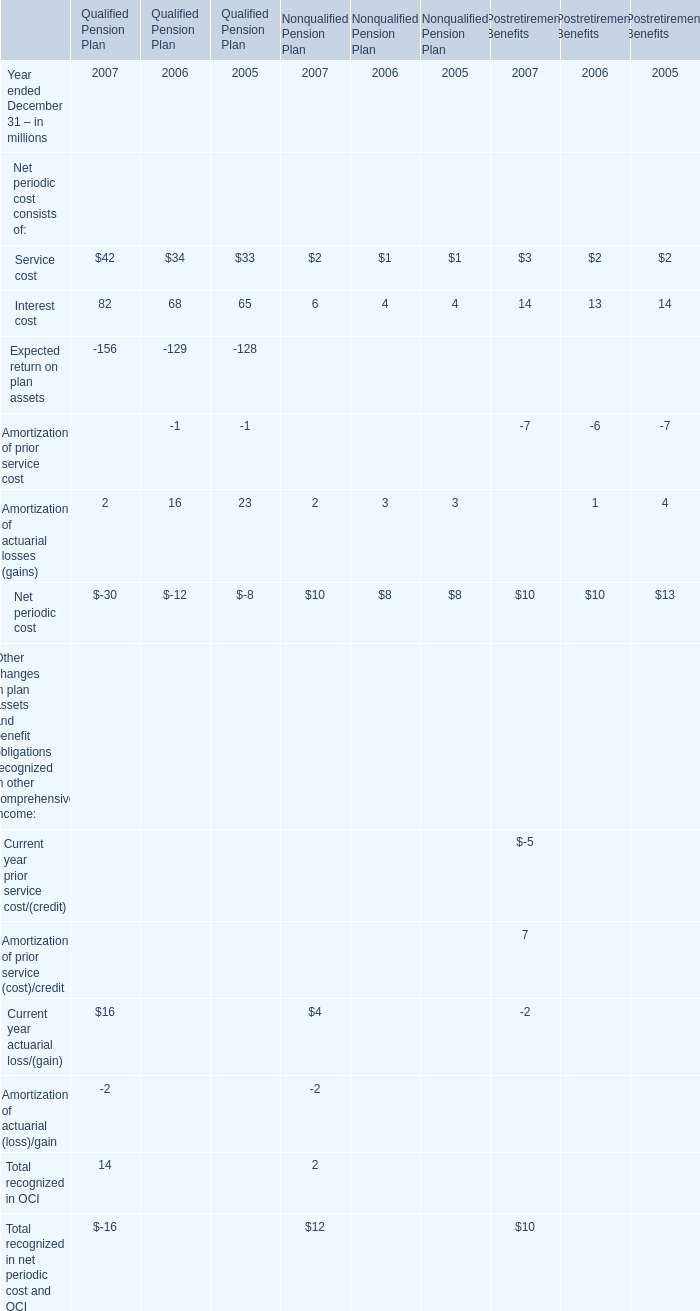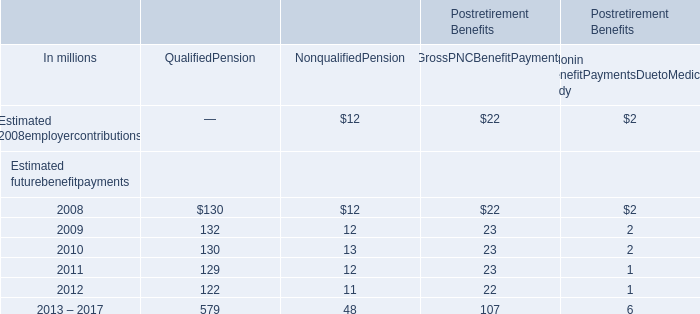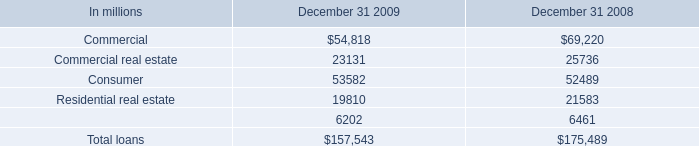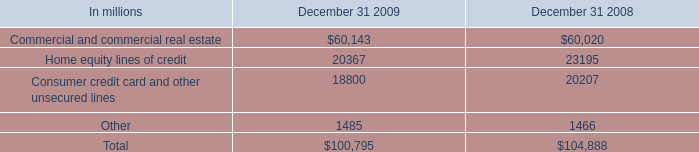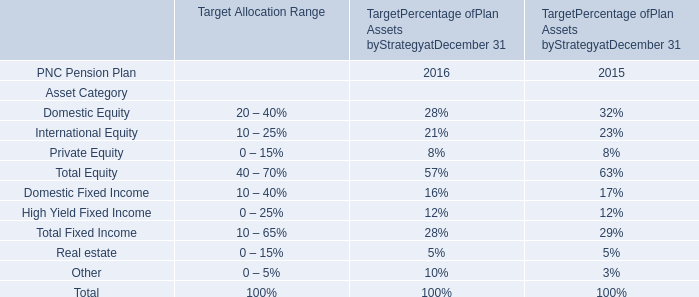If Interest cost for Qualified Pension Plan develops with the same growth rate in 2007, what will it reach in 2008? (in million) 
Computations: (82 * (1 + ((82 - 68) / 68)))
Answer: 98.88235. 